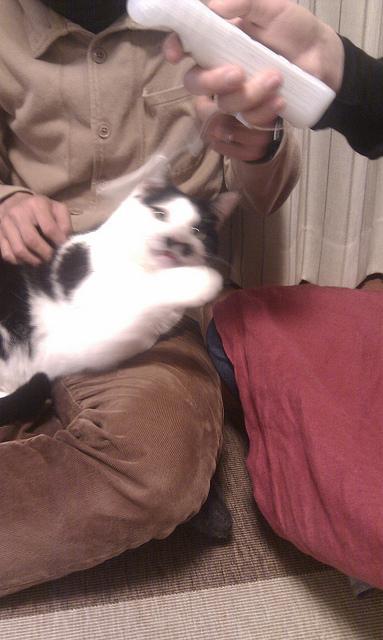What kind of animal is this?
Concise answer only. Cat. What is the cat doing on it's side?
Write a very short answer. Playing. Where is cat?
Give a very brief answer. Lap. What kind of animal is sitting in the man's lap?
Keep it brief. Cat. What is being held?
Quick response, please. Cat. What is the cat pawing at?
Keep it brief. Strap. 